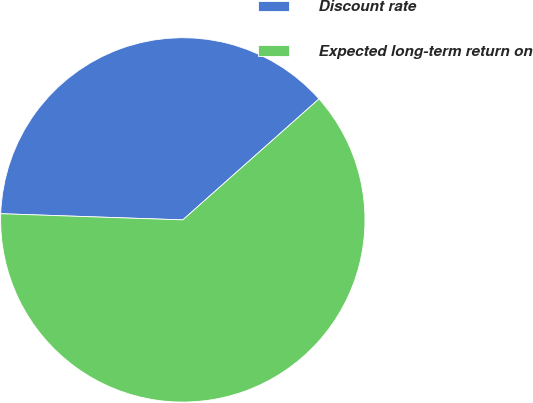Convert chart to OTSL. <chart><loc_0><loc_0><loc_500><loc_500><pie_chart><fcel>Discount rate<fcel>Expected long-term return on<nl><fcel>37.9%<fcel>62.1%<nl></chart> 